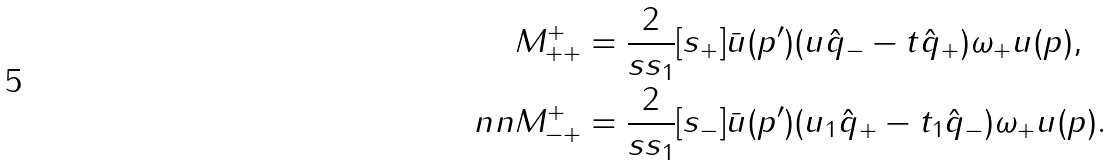<formula> <loc_0><loc_0><loc_500><loc_500>& M ^ { + } _ { + + } = \frac { 2 } { s s _ { 1 } } [ s _ { + } ] \bar { u } ( p ^ { \prime } ) ( u \hat { q } _ { - } - t \hat { q } _ { + } ) \omega _ { + } u ( p ) , \\ \ n n & M ^ { + } _ { - + } = \frac { 2 } { s s _ { 1 } } [ s _ { - } ] \bar { u } ( p ^ { \prime } ) ( u _ { 1 } \hat { q } _ { + } - t _ { 1 } \hat { q } _ { - } ) \omega _ { + } u ( p ) .</formula> 